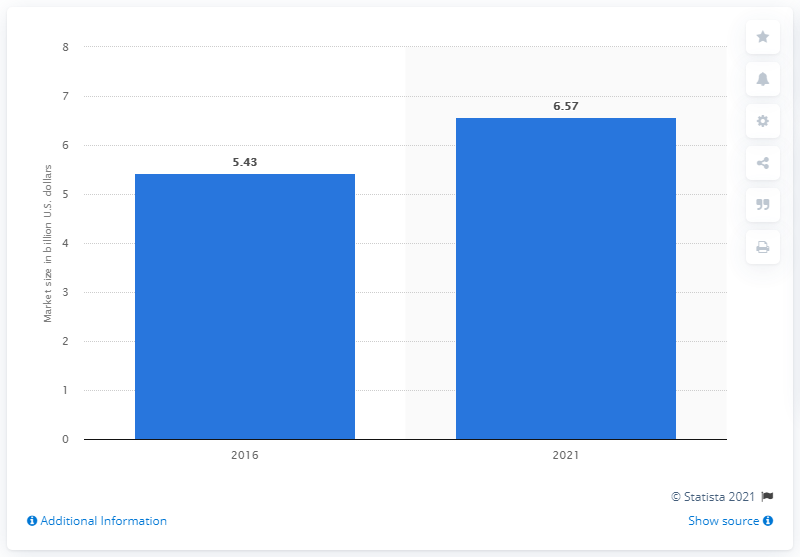Outline some significant characteristics in this image. The estimated value of the assistive walking devices market by 2021 is estimated to be $6.57 billion. 